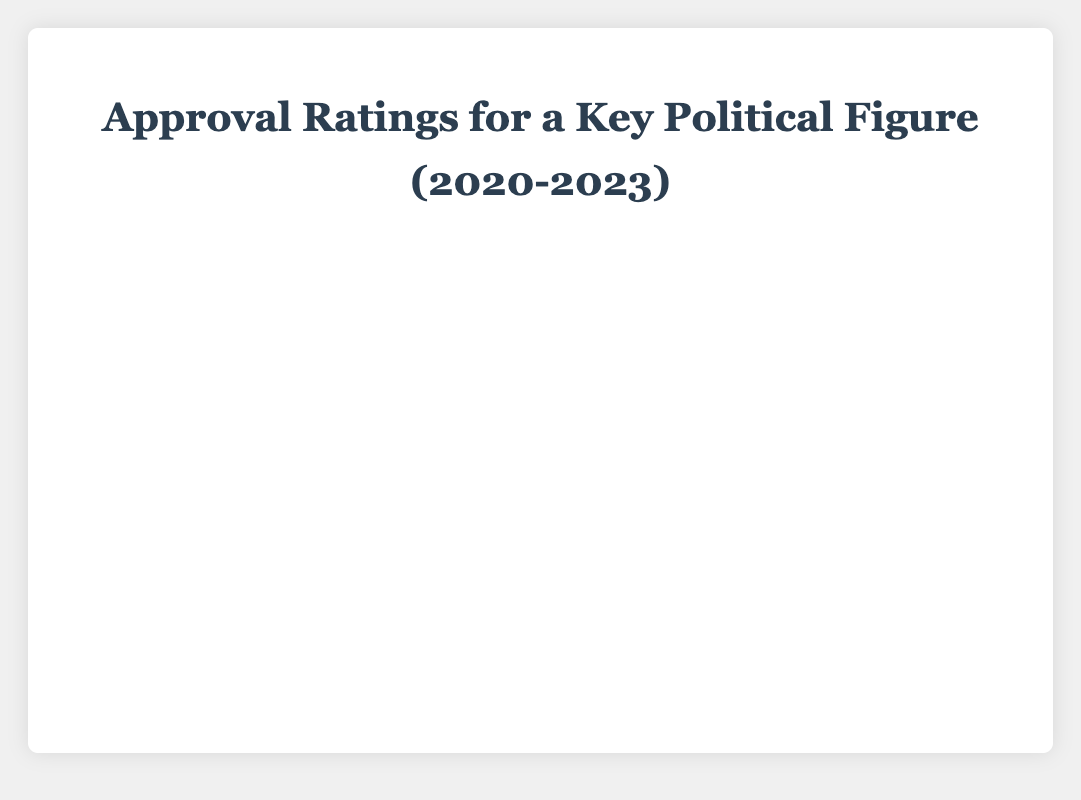How did the approval rating change from January 2020 to April 2020? The approval rating on January 2020 was 55, and on April 2020, it was 48. The change is calculated by subtracting the April value from the January value: 55 - 48 = 7.
Answer: 7 What was the highest approval rating recorded, and when did it occur? The highest approval rating is 55, which occurred in January 2020 and May 2022.
Answer: 55 Between which two consecutive months did the approval rating see the largest decrease? To find the largest decrease, compare the differences between consecutive months. The largest decrease occurs between September 2020 (50) and October 2020 (45), with a decrease of 50 - 45 = 5.
Answer: September 2020 to October 2020 What is the average approval rating for the entire period? Sum all the approval ratings and divide by the number of months: (55 + 53 + 50 + 48 + 47 + 49 + 51 + 52 + 50 + 45 + 46 + 44 + 47 + 49 + 48 + 47 + 46 + 45 + 44 + 43 + 42 + 45 + 46 + 47 + 48 + 50 + 52 + 54 + 55 + 53 + 51 + 50 + 48 + 47 + 46 + 44 + 45 + 43 + 42 + 41) / 40 = 47.55.
Answer: 47.55 Is the approval rating in November 2022 higher or lower than in November 2020? The approval rating in November 2022 is 46, and in November 2020, it is 46. They are equal.
Answer: Equal When did the approval rating fall below 50 for the first time? The first time the approval rating fell below 50 was in March 2020, when it was 50 before but dropped to 48.
Answer: March 2020 Which month had a sudden increase in approval rating, and by how much? The month of October 2021 saw a sudden increase from 42 to 45, an increase of 3.
Answer: October 2021, 3 During which period did the approval rating remain constant, and what was the rating? The approval rating remained constant at 47 from November 2021 to January 2022.
Answer: November 2021 to January 2022, 47 What was the trend in the approval rating from January 2023 to April 2023? The trend showed a consistent decline from 45 in January 2023 to 41 in April 2023.
Answer: Decline 